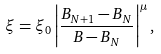Convert formula to latex. <formula><loc_0><loc_0><loc_500><loc_500>\xi = \xi _ { 0 } \left | \frac { B _ { N + 1 } - B _ { N } } { B - B _ { N } } \right | ^ { \mu } ,</formula> 